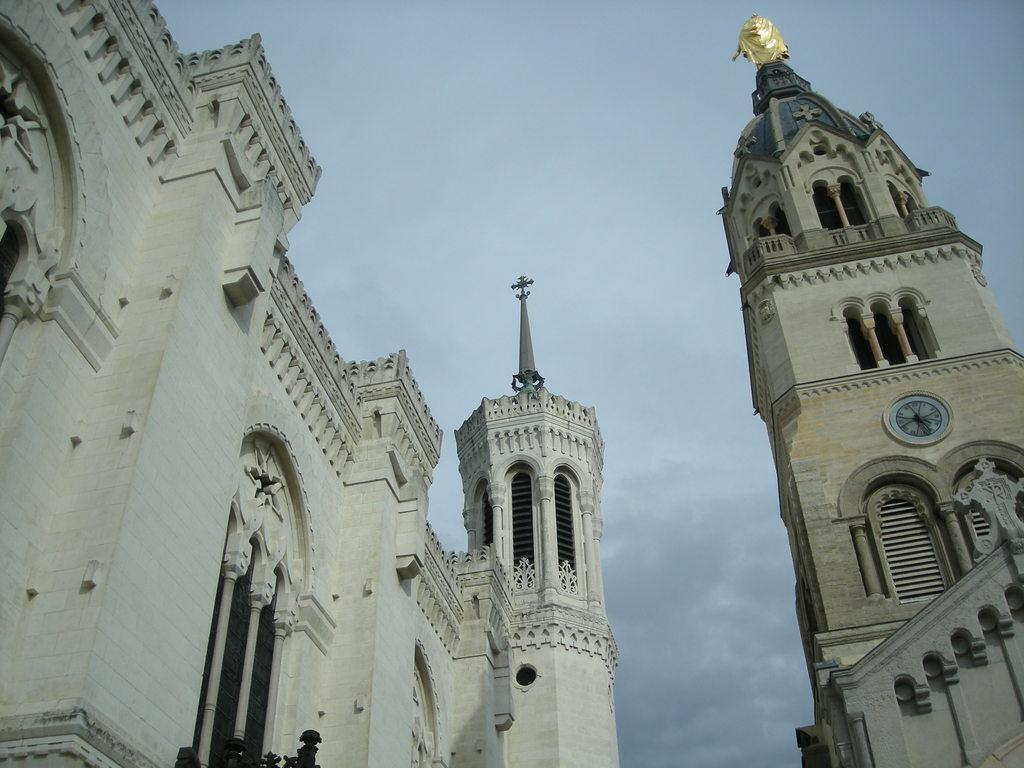What structures are located at the front of the image? There are buildings in the front of the image. What can be seen in the middle of the buildings? There is a clock in the middle of the buildings. What is visible in the background of the image? The sky is visible in the image. What type of weather can be inferred from the image? Clouds are present in the sky, suggesting that it might be a partly cloudy day. What type of loaf is being used to measure time on the clock in the image? There is no loaf present in the image, and the clock does not use a loaf to measure time. 